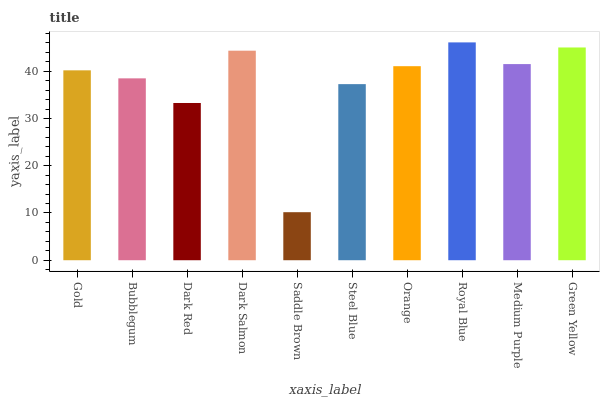Is Saddle Brown the minimum?
Answer yes or no. Yes. Is Royal Blue the maximum?
Answer yes or no. Yes. Is Bubblegum the minimum?
Answer yes or no. No. Is Bubblegum the maximum?
Answer yes or no. No. Is Gold greater than Bubblegum?
Answer yes or no. Yes. Is Bubblegum less than Gold?
Answer yes or no. Yes. Is Bubblegum greater than Gold?
Answer yes or no. No. Is Gold less than Bubblegum?
Answer yes or no. No. Is Orange the high median?
Answer yes or no. Yes. Is Gold the low median?
Answer yes or no. Yes. Is Steel Blue the high median?
Answer yes or no. No. Is Bubblegum the low median?
Answer yes or no. No. 